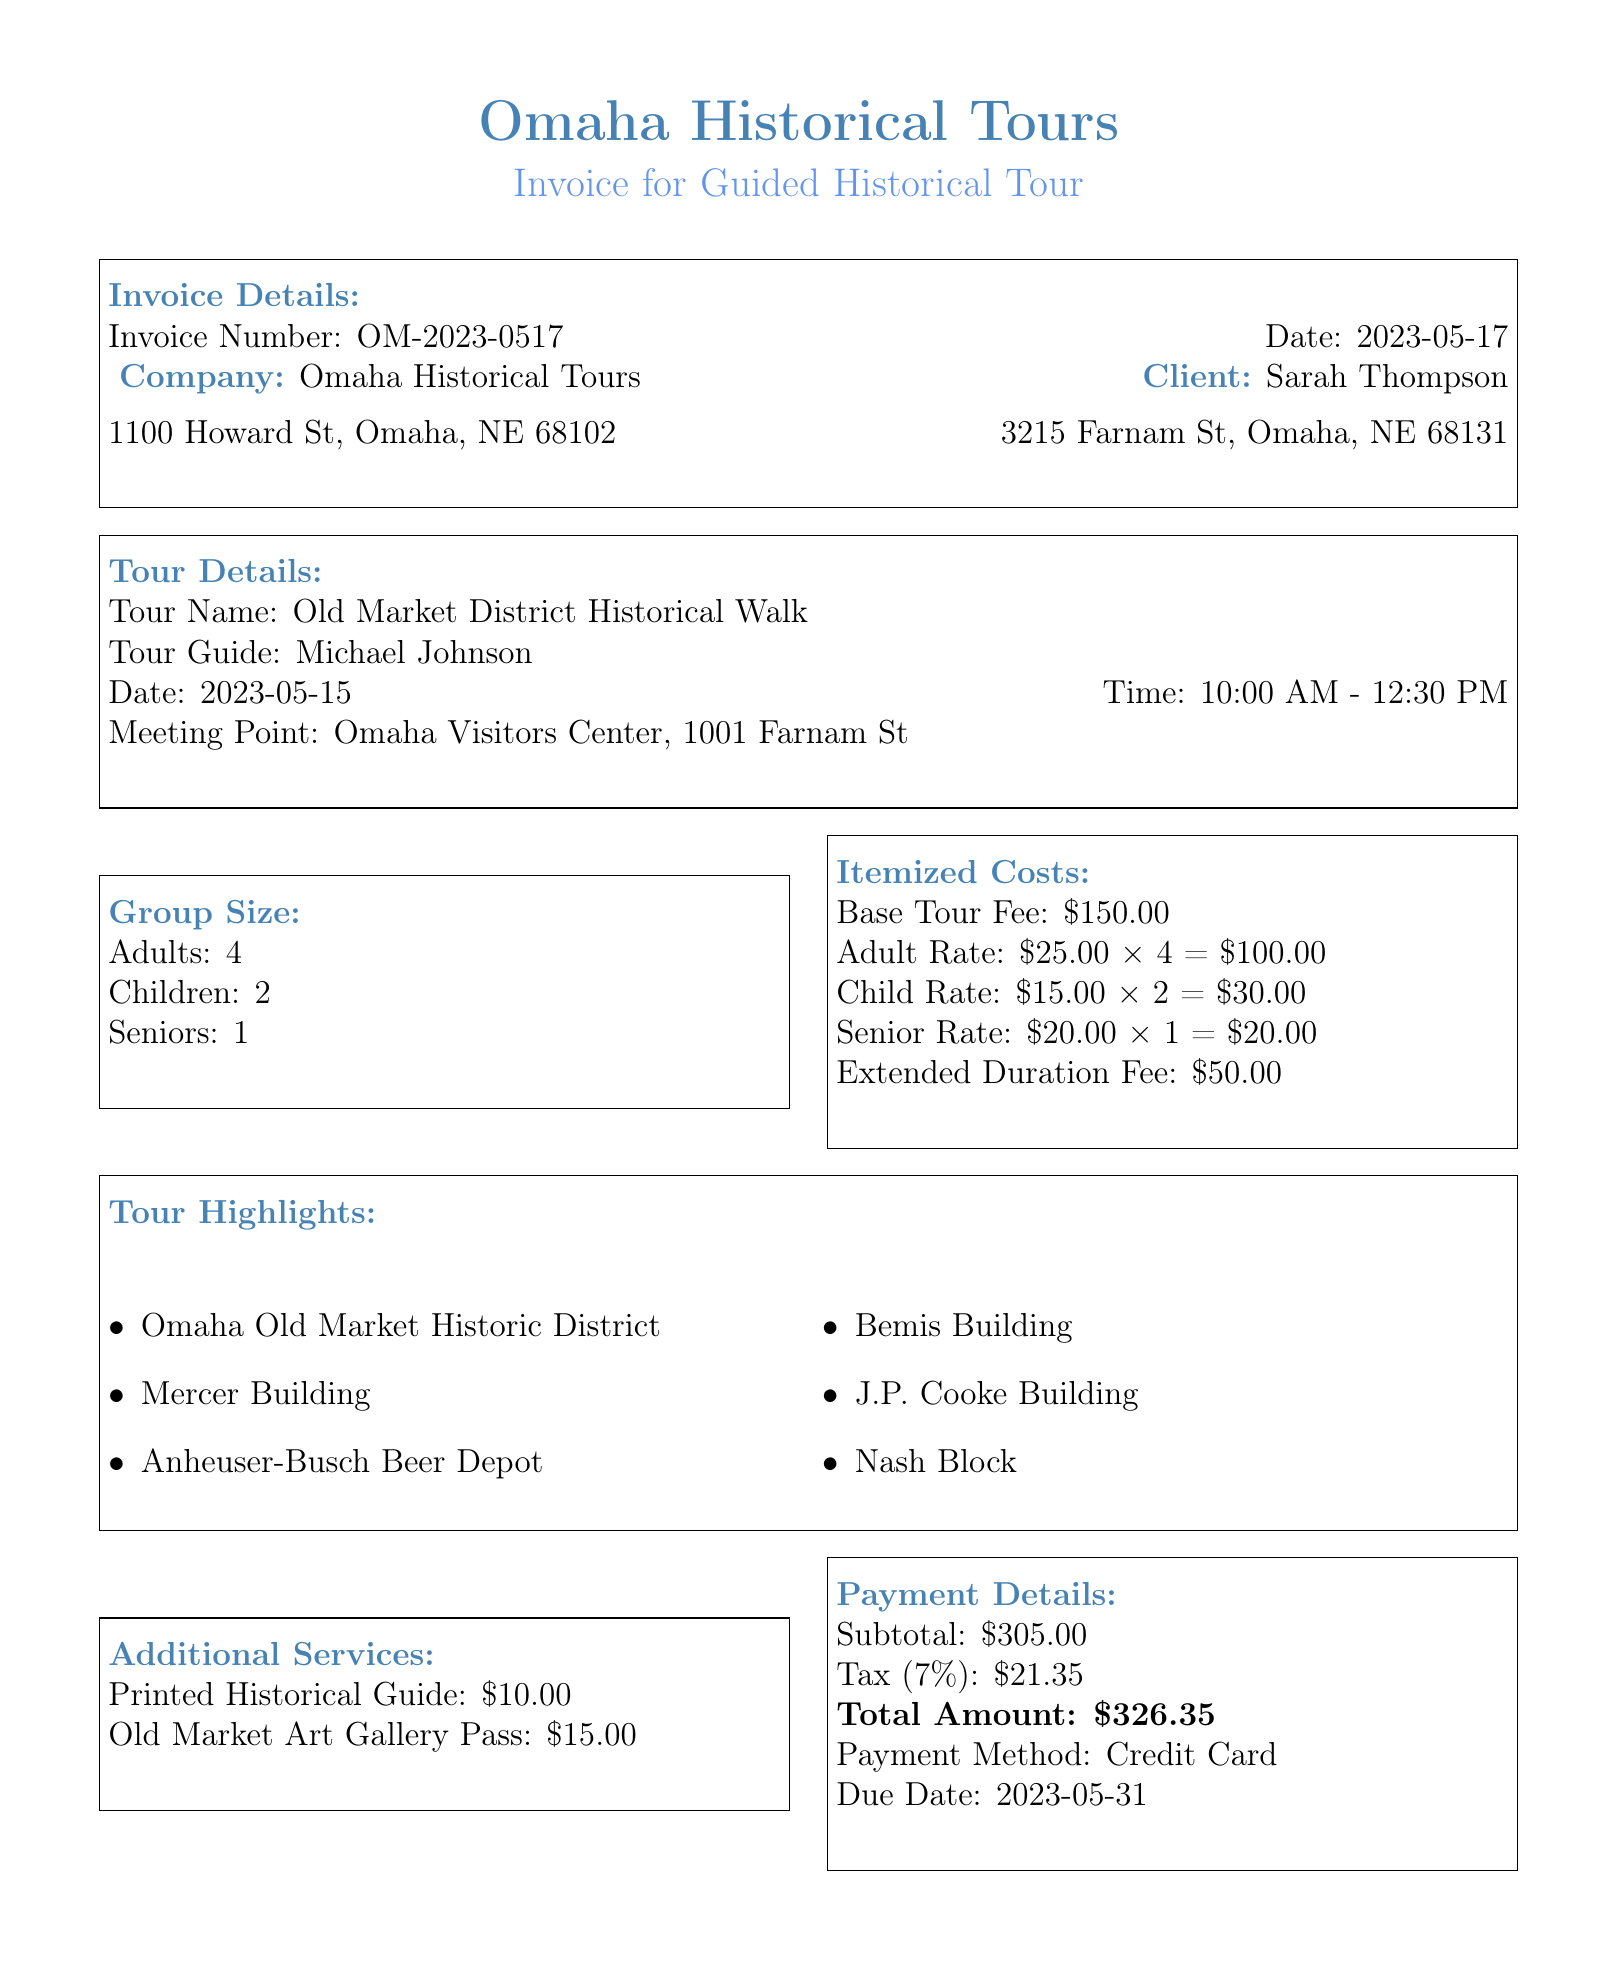What is the invoice number? The invoice number is stated in the invoice details section of the document.
Answer: OM-2023-0517 Who is the tour guide for the event? The name of the tour guide is mentioned under the tour details section.
Answer: Michael Johnson How many children are included in the group size? The document lists the number of children in the group size section.
Answer: 2 What is the total amount due for the tour? The total amount is calculated in the payment details section, including taxes.
Answer: 326.35 What date is the payment due? The payment due date is found in the payment details section of the document.
Answer: 2023-05-31 What is the base tour fee? The base tour fee is specified in the itemized costs section.
Answer: 150.00 How many adults are part of the group? The number of adults in the group size is provided in the document.
Answer: 4 What is the cancellation policy for the tour? The cancellation policy is detailed towards the end of the document.
Answer: Full refund if cancelled 48 hours before the tour What additional service costs for the Printed Historical Guide? The cost of the Printed Historical Guide is listed in the additional services section.
Answer: 10.00 